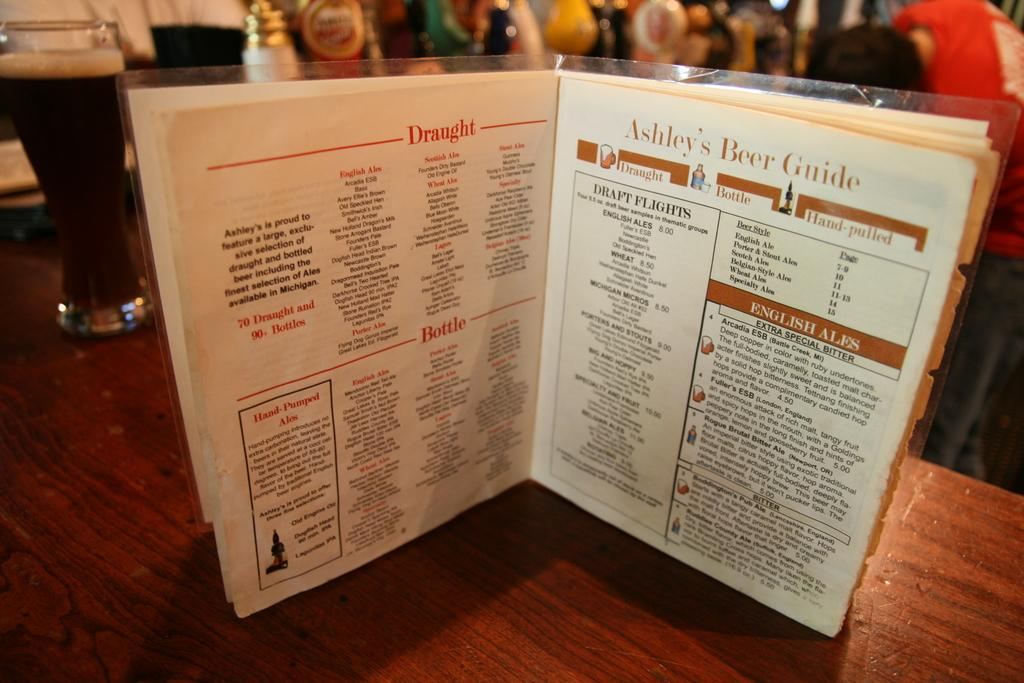<image>
Provide a brief description of the given image. A restaurant menu with Ashley's Beer Guide printed on top. 